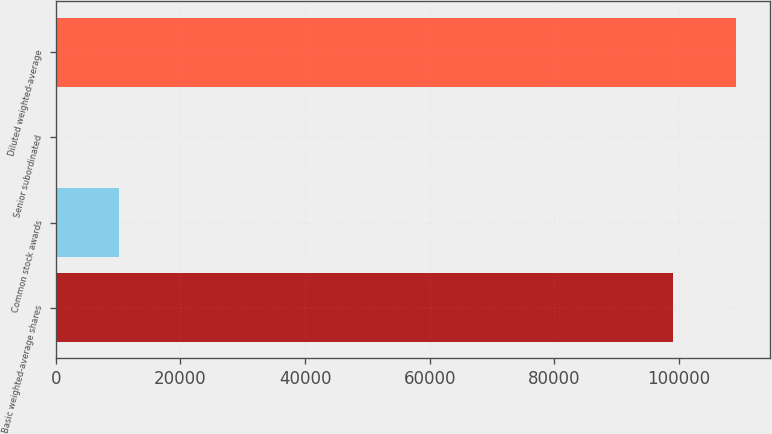Convert chart. <chart><loc_0><loc_0><loc_500><loc_500><bar_chart><fcel>Basic weighted-average shares<fcel>Common stock awards<fcel>Senior subordinated<fcel>Diluted weighted-average<nl><fcel>99123<fcel>10196.4<fcel>195<fcel>109124<nl></chart> 